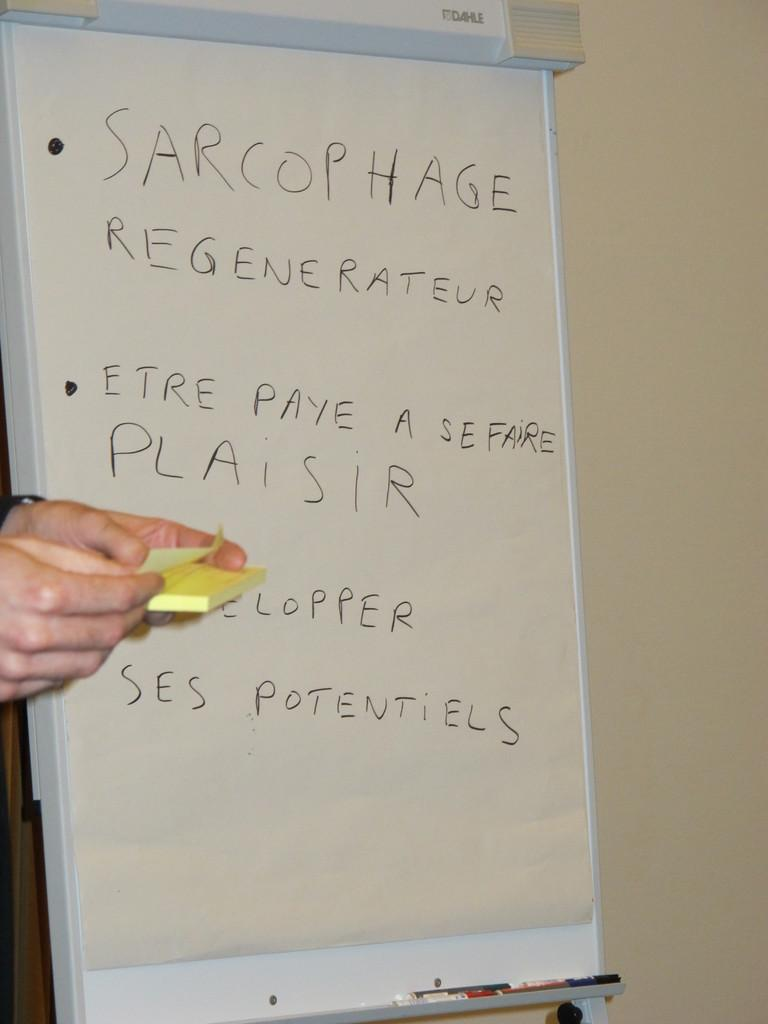<image>
Render a clear and concise summary of the photo. the word sarcophage that is on a white board 